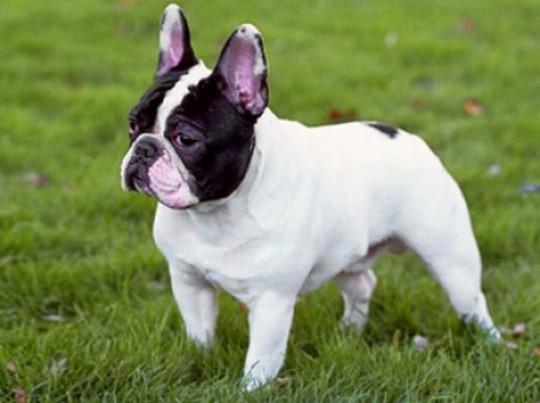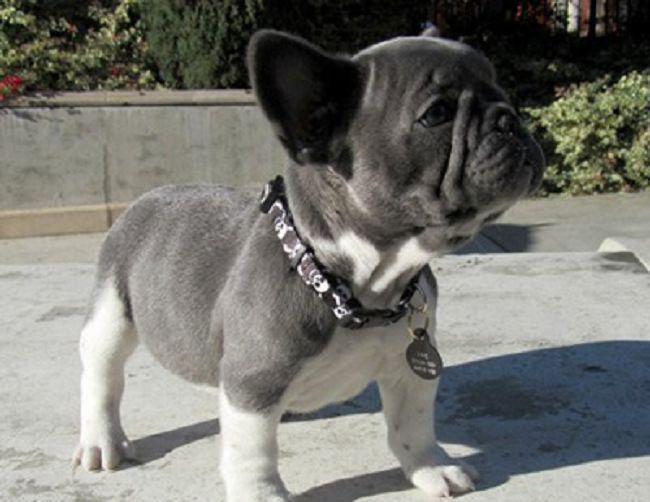The first image is the image on the left, the second image is the image on the right. Assess this claim about the two images: "An image shows exactly one gray big-eared dog, and it is wearing something.". Correct or not? Answer yes or no. Yes. The first image is the image on the left, the second image is the image on the right. Given the left and right images, does the statement "Two dogs are relaxing on the ground." hold true? Answer yes or no. No. 